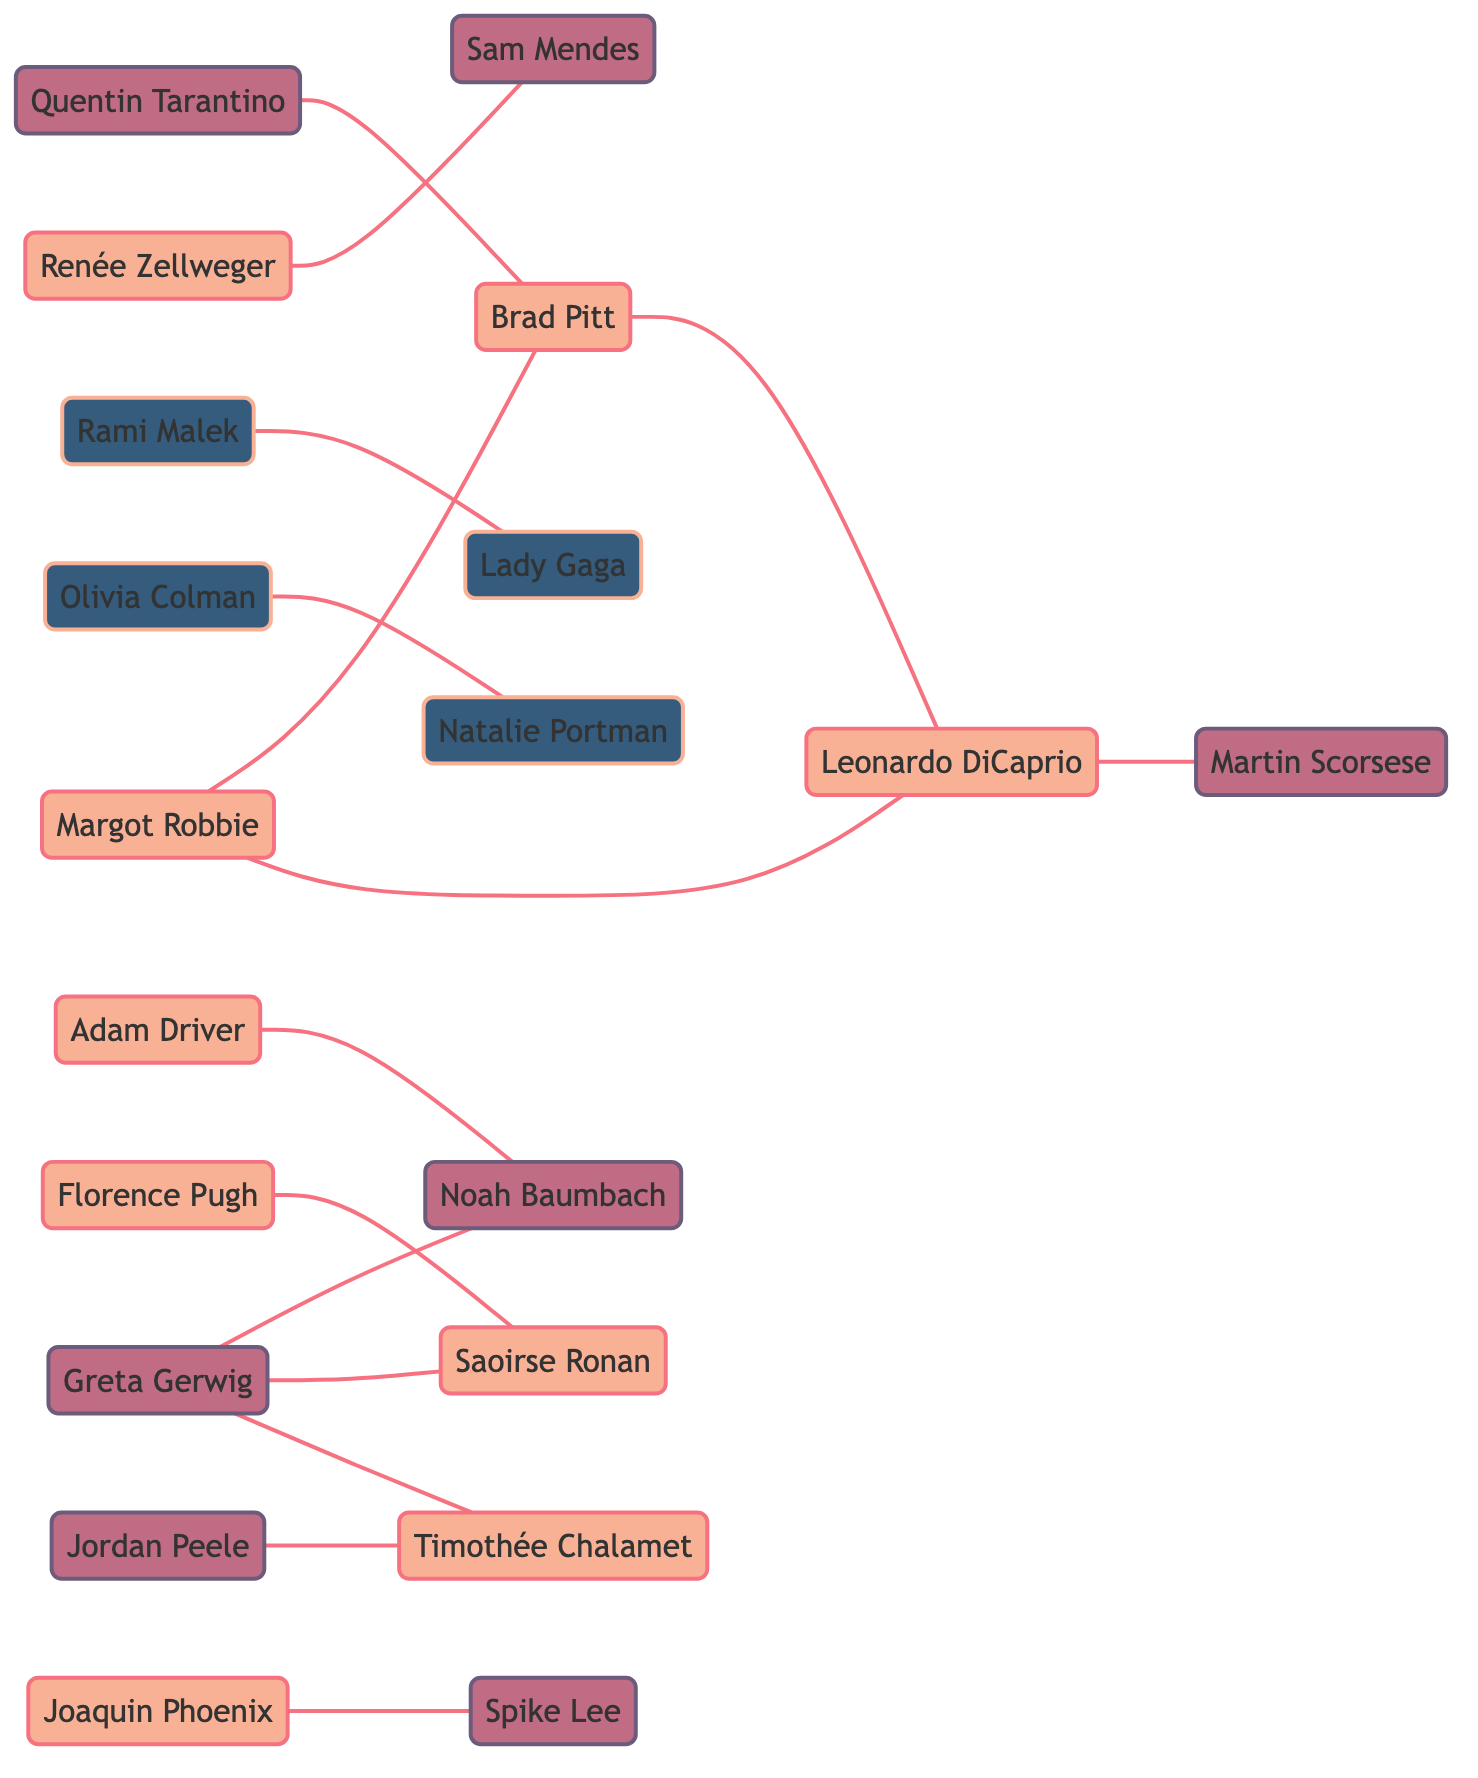What is the total number of nodes in the diagram? The total number of nodes can be counted directly from the provided data. There are 20 unique names listed under the "nodes" section.
Answer: 20 Who directed Leonardo DiCaprio? By examining the edges connected to Leonardo DiCaprio, we see that he is linked to Martin Scorsese, who is labeled as the director.
Answer: Martin Scorsese Which actor is connected to both Brad Pitt and Leonardo DiCaprio? Margot Robbie is connected to both Brad Pitt and Leonardo DiCaprio as indicated by the edges labeled "co-actors" that link her to both actors.
Answer: Margot Robbie How many directors are present in the network? To find the number of directors, we look at the "nodes" section and identify those labeled as directors. There are 5 directors listed: Martin Scorsese, Quentin Tarantino, Sam Mendes, Greta Gerwig, and Spike Lee.
Answer: 5 Which nominees are directly linked to Timothée Chalamet? By reviewing the edges connected to Timothée Chalamet, we can see that he is directly linked to Greta Gerwig as a director and to Jordan Peele as a nominee.
Answer: Jordan Peele What type of relationship exists between Rami Malek and Lady Gaga? The edge connecting Rami Malek and Lady Gaga is labeled "nominees," indicating that they share a nomination connection in the context of the Golden Globes.
Answer: nominees Is there any actor who shares co-actor connections with both Greta Gerwig and Noah Baumbach? Looking at the edges, we find that Saoirse Ronan is connected to Greta Gerwig (as a director) and has a co-actor connection with Florence Pugh, but there are no direct edges connecting her to Noah Baumbach, so she is not a co-actor in this context.
Answer: No How is Margot Robbie related to Quentin Tarantino? Margot Robbie is connected to Quentin Tarantino through an edge labeled "co-actors" to Brad Pitt, who is also connected to Quentin Tarantino, indicating they have collaborated together in a film directed by him.
Answer: co-actors Who are the partners listed in the diagram? The diagram indicates that Greta Gerwig and Noah Baumbach are linked by the edge labeled "partners," which explicitly denotes their personal and professional relationship.
Answer: Greta Gerwig and Noah Baumbach 